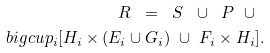Convert formula to latex. <formula><loc_0><loc_0><loc_500><loc_500>R \ = \ S \ \cup \ P \ \cup \ \\ b i g c u p _ { i } [ H _ { i } \times ( E _ { i } \cup G _ { i } ) \ \cup \ F _ { i } \times H _ { i } ] .</formula> 